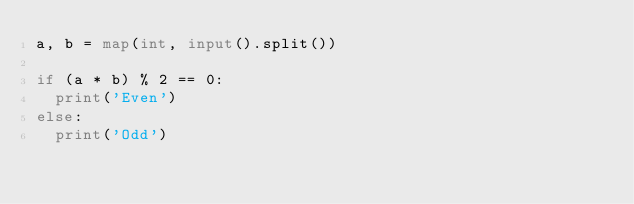<code> <loc_0><loc_0><loc_500><loc_500><_Python_>a, b = map(int, input().split())

if (a * b) % 2 == 0:
  print('Even')
else:
  print('Odd')</code> 